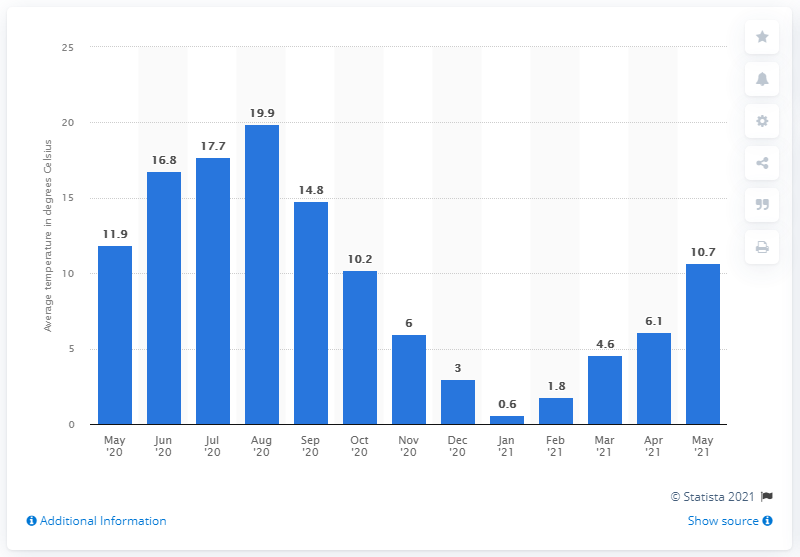Outline some significant characteristics in this image. According to data from May 2021, the average temperature in Germany was 10.7 degrees Celsius. 